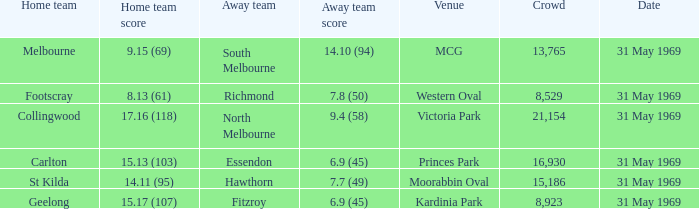In the event where the home team registered 1 Fitzroy. 